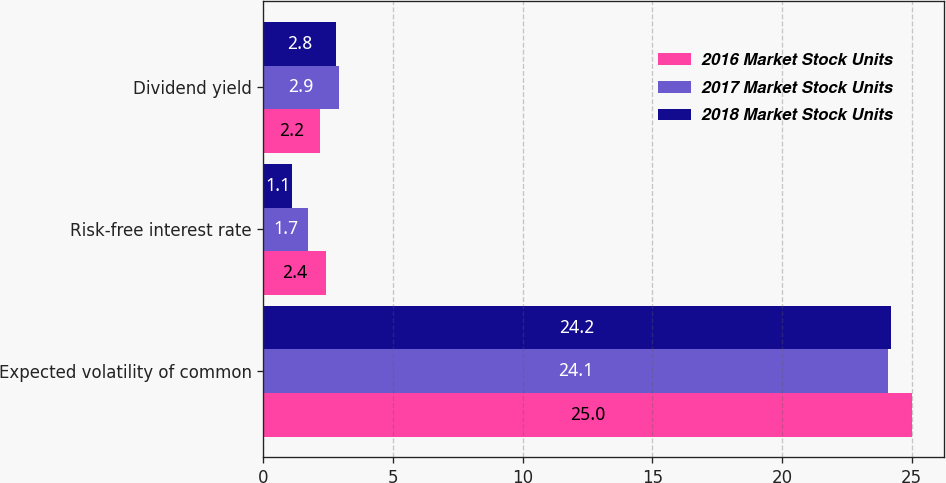Convert chart to OTSL. <chart><loc_0><loc_0><loc_500><loc_500><stacked_bar_chart><ecel><fcel>Expected volatility of common<fcel>Risk-free interest rate<fcel>Dividend yield<nl><fcel>2016 Market Stock Units<fcel>25<fcel>2.4<fcel>2.2<nl><fcel>2017 Market Stock Units<fcel>24.1<fcel>1.7<fcel>2.9<nl><fcel>2018 Market Stock Units<fcel>24.2<fcel>1.1<fcel>2.8<nl></chart> 